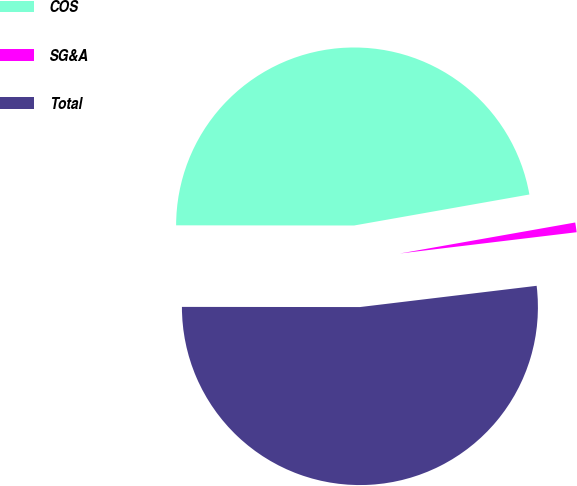<chart> <loc_0><loc_0><loc_500><loc_500><pie_chart><fcel>COS<fcel>SG&A<fcel>Total<nl><fcel>47.2%<fcel>0.88%<fcel>51.92%<nl></chart> 